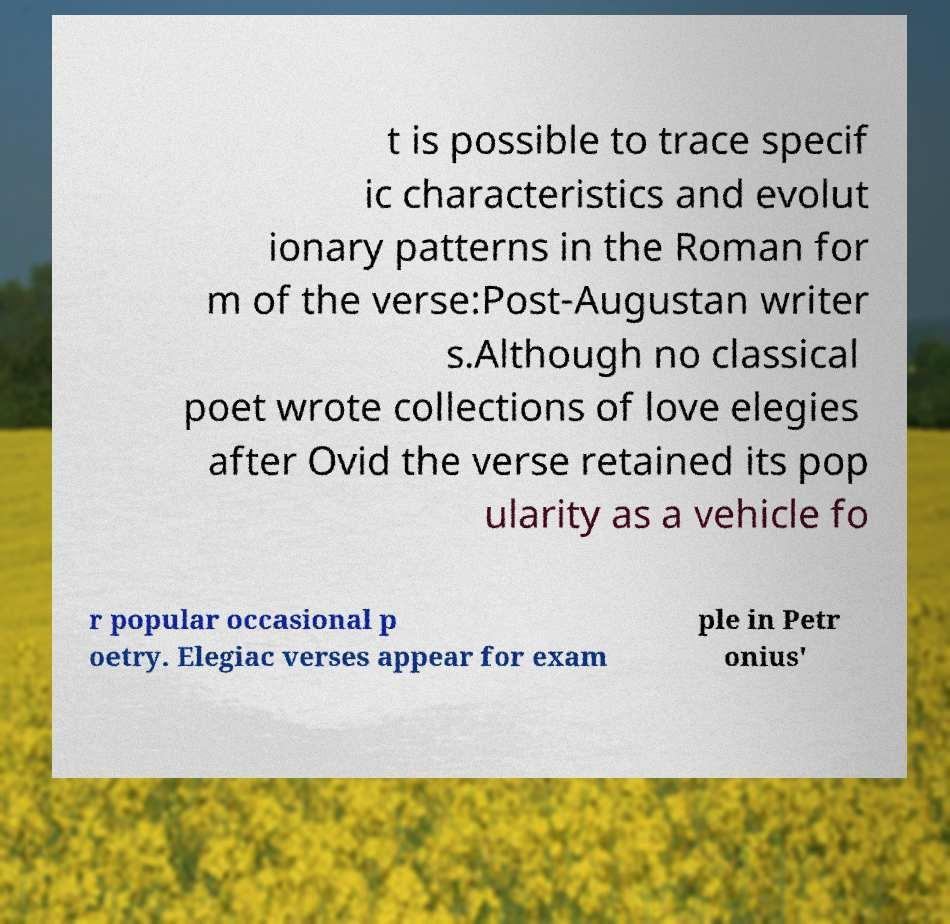Can you accurately transcribe the text from the provided image for me? t is possible to trace specif ic characteristics and evolut ionary patterns in the Roman for m of the verse:Post-Augustan writer s.Although no classical poet wrote collections of love elegies after Ovid the verse retained its pop ularity as a vehicle fo r popular occasional p oetry. Elegiac verses appear for exam ple in Petr onius' 